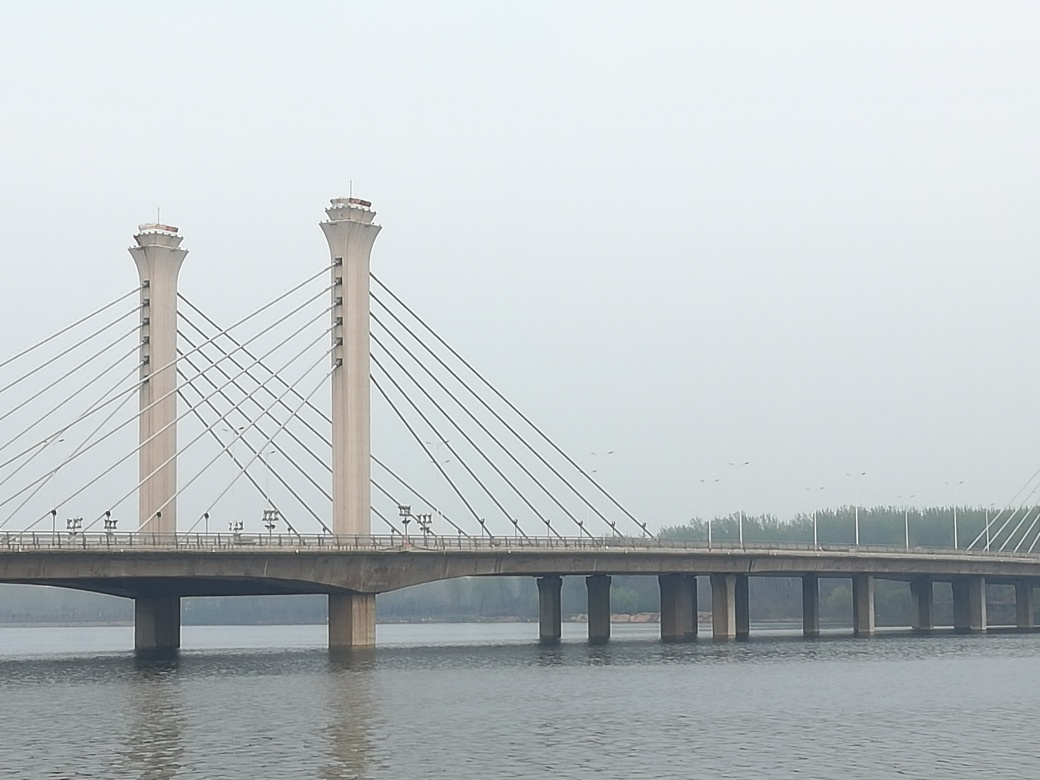Can you comment on the weather conditions at the time this photo was taken? The lighting in the image is soft and diffuse, without harsh shadows or bright sunlight, which often indicates an overcast day. The slight haze reducing visibility points to the likelihood of high humidity or airborne particulates, suggesting early morning fog or smog from pollution. How might the weather affect the use of this bridge? Weather conditions like fog can reduce visibility, which might impact the traffic flow on the bridge, leading to slower driving speeds and potentially increased risk of accidents. Additionally, if this is a high-pollution area, consistent exposure could contribute to the deterioration of the bridge materials over time, requiring more frequent maintenance. 